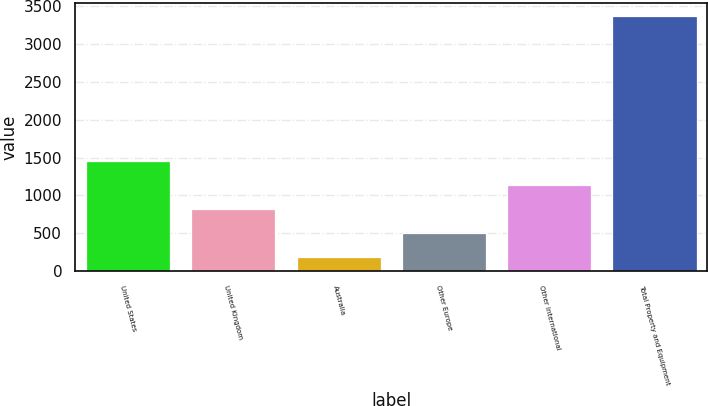Convert chart. <chart><loc_0><loc_0><loc_500><loc_500><bar_chart><fcel>United States<fcel>United Kingdom<fcel>Australia<fcel>Other Europe<fcel>Other International<fcel>Total Property and Equipment<nl><fcel>1459.8<fcel>825.4<fcel>191<fcel>508.2<fcel>1142.6<fcel>3363<nl></chart> 